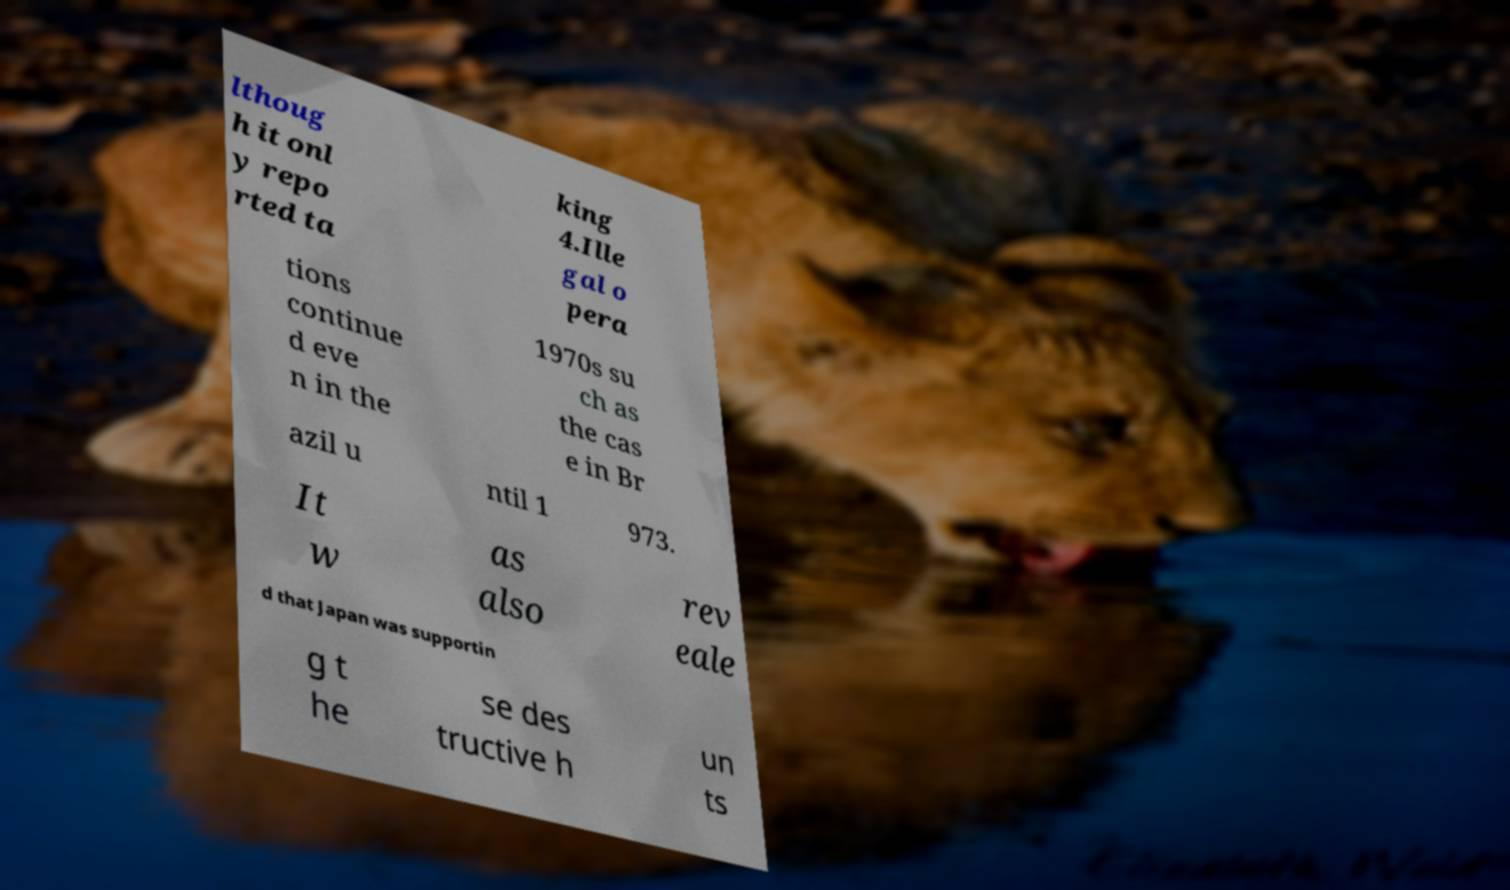I need the written content from this picture converted into text. Can you do that? lthoug h it onl y repo rted ta king 4.Ille gal o pera tions continue d eve n in the 1970s su ch as the cas e in Br azil u ntil 1 973. It w as also rev eale d that Japan was supportin g t he se des tructive h un ts 